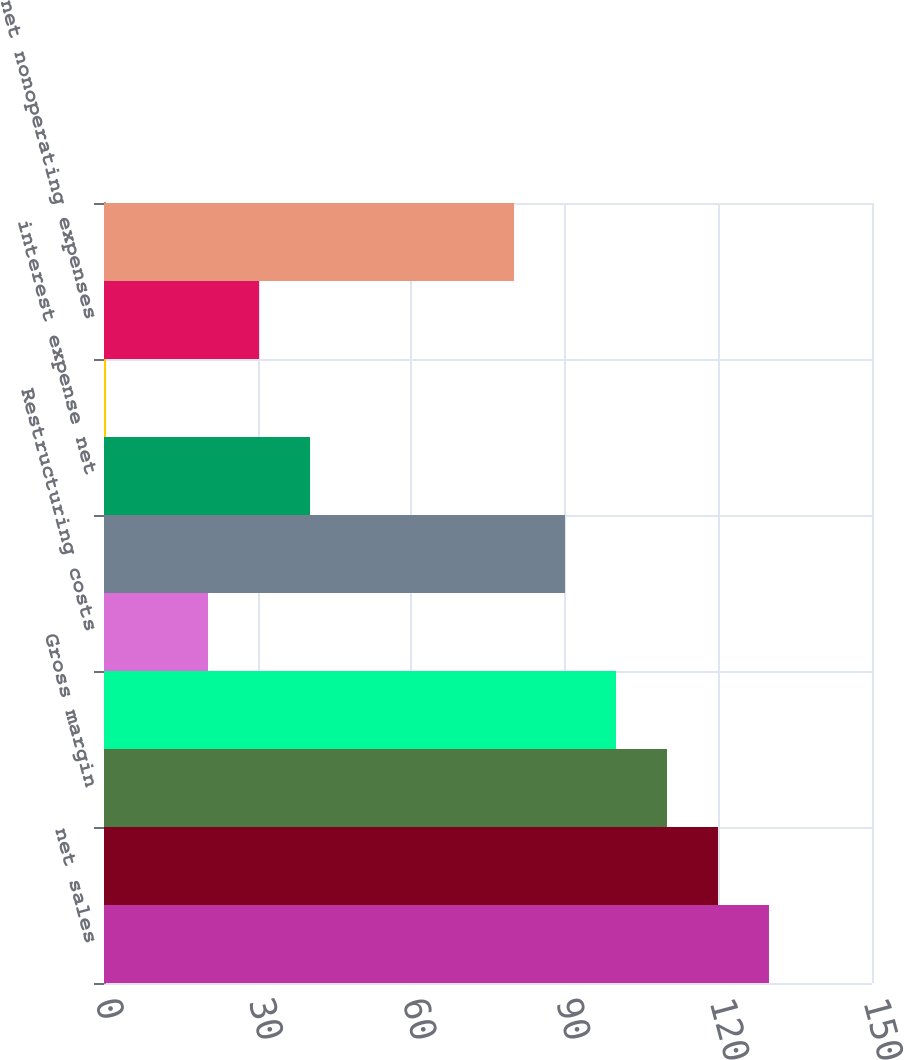<chart> <loc_0><loc_0><loc_500><loc_500><bar_chart><fcel>net sales<fcel>cost of products sold<fcel>Gross margin<fcel>Selling general and<fcel>Restructuring costs<fcel>operating income<fcel>interest expense net<fcel>other expense (income) net<fcel>net nonoperating expenses<fcel>income from continuing<nl><fcel>129.88<fcel>119.92<fcel>109.96<fcel>100<fcel>20.32<fcel>90.04<fcel>40.24<fcel>0.4<fcel>30.28<fcel>80.08<nl></chart> 